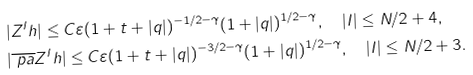<formula> <loc_0><loc_0><loc_500><loc_500>& | Z ^ { I } h | \leq C \varepsilon ( 1 + t + | q | ) ^ { - 1 / 2 - \gamma } ( 1 + | q | ) ^ { 1 / 2 - \gamma } , \quad | I | \leq N / 2 + 4 , \\ & | \overline { \ p a } Z ^ { I } h | \leq C \varepsilon ( 1 + t + | q | ) ^ { - 3 / 2 - \gamma } ( 1 + | q | ) ^ { 1 / 2 - \gamma } , \quad | I | \leq N / 2 + 3 .</formula> 